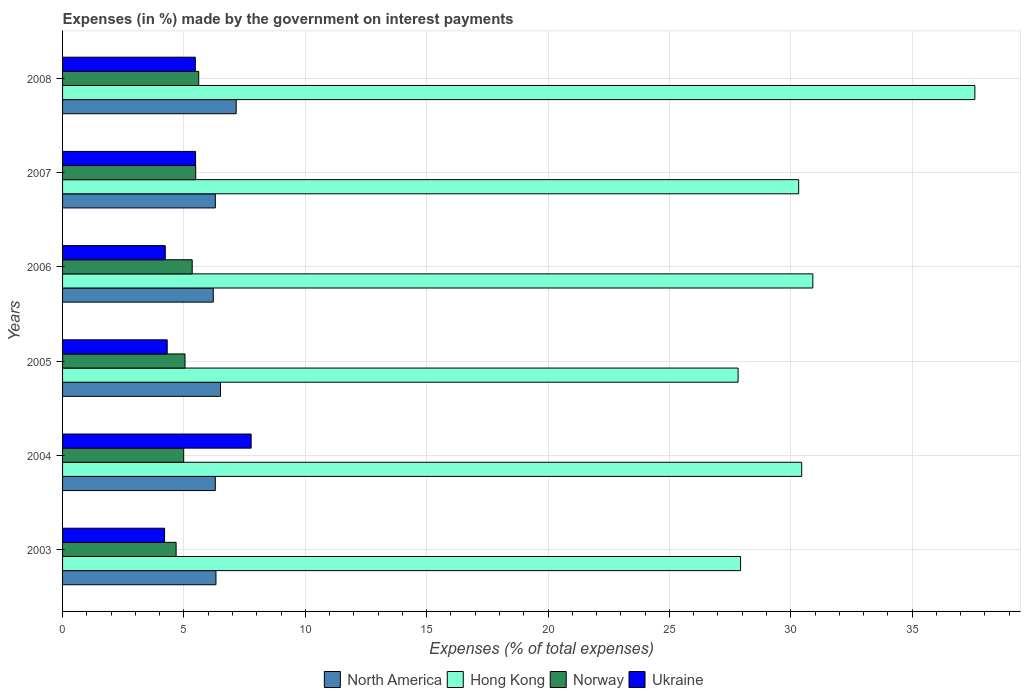How many different coloured bars are there?
Make the answer very short. 4. Are the number of bars per tick equal to the number of legend labels?
Give a very brief answer. Yes. Are the number of bars on each tick of the Y-axis equal?
Keep it short and to the point. Yes. What is the label of the 6th group of bars from the top?
Give a very brief answer. 2003. In how many cases, is the number of bars for a given year not equal to the number of legend labels?
Provide a succinct answer. 0. What is the percentage of expenses made by the government on interest payments in North America in 2003?
Your answer should be compact. 6.32. Across all years, what is the maximum percentage of expenses made by the government on interest payments in Ukraine?
Provide a succinct answer. 7.77. Across all years, what is the minimum percentage of expenses made by the government on interest payments in North America?
Your response must be concise. 6.21. In which year was the percentage of expenses made by the government on interest payments in Norway maximum?
Your response must be concise. 2008. In which year was the percentage of expenses made by the government on interest payments in Ukraine minimum?
Your answer should be very brief. 2003. What is the total percentage of expenses made by the government on interest payments in North America in the graph?
Make the answer very short. 38.77. What is the difference between the percentage of expenses made by the government on interest payments in Ukraine in 2004 and that in 2007?
Provide a short and direct response. 2.29. What is the difference between the percentage of expenses made by the government on interest payments in Norway in 2004 and the percentage of expenses made by the government on interest payments in Hong Kong in 2007?
Keep it short and to the point. -25.34. What is the average percentage of expenses made by the government on interest payments in Ukraine per year?
Your answer should be very brief. 5.24. In the year 2007, what is the difference between the percentage of expenses made by the government on interest payments in Norway and percentage of expenses made by the government on interest payments in Ukraine?
Give a very brief answer. 0.01. In how many years, is the percentage of expenses made by the government on interest payments in Hong Kong greater than 26 %?
Keep it short and to the point. 6. What is the ratio of the percentage of expenses made by the government on interest payments in Hong Kong in 2003 to that in 2008?
Give a very brief answer. 0.74. Is the percentage of expenses made by the government on interest payments in North America in 2004 less than that in 2007?
Make the answer very short. Yes. Is the difference between the percentage of expenses made by the government on interest payments in Norway in 2003 and 2005 greater than the difference between the percentage of expenses made by the government on interest payments in Ukraine in 2003 and 2005?
Your response must be concise. No. What is the difference between the highest and the second highest percentage of expenses made by the government on interest payments in North America?
Keep it short and to the point. 0.65. What is the difference between the highest and the lowest percentage of expenses made by the government on interest payments in Hong Kong?
Provide a succinct answer. 9.76. What does the 4th bar from the top in 2008 represents?
Ensure brevity in your answer.  North America. What does the 4th bar from the bottom in 2007 represents?
Provide a succinct answer. Ukraine. Are the values on the major ticks of X-axis written in scientific E-notation?
Your response must be concise. No. How many legend labels are there?
Offer a very short reply. 4. How are the legend labels stacked?
Offer a terse response. Horizontal. What is the title of the graph?
Offer a terse response. Expenses (in %) made by the government on interest payments. Does "Malawi" appear as one of the legend labels in the graph?
Your answer should be compact. No. What is the label or title of the X-axis?
Provide a succinct answer. Expenses (% of total expenses). What is the label or title of the Y-axis?
Make the answer very short. Years. What is the Expenses (% of total expenses) of North America in 2003?
Give a very brief answer. 6.32. What is the Expenses (% of total expenses) of Hong Kong in 2003?
Offer a terse response. 27.93. What is the Expenses (% of total expenses) of Norway in 2003?
Provide a short and direct response. 4.68. What is the Expenses (% of total expenses) of Ukraine in 2003?
Give a very brief answer. 4.2. What is the Expenses (% of total expenses) of North America in 2004?
Your answer should be compact. 6.29. What is the Expenses (% of total expenses) in Hong Kong in 2004?
Make the answer very short. 30.45. What is the Expenses (% of total expenses) in Norway in 2004?
Ensure brevity in your answer.  4.99. What is the Expenses (% of total expenses) in Ukraine in 2004?
Offer a terse response. 7.77. What is the Expenses (% of total expenses) in North America in 2005?
Your answer should be very brief. 6.51. What is the Expenses (% of total expenses) of Hong Kong in 2005?
Your response must be concise. 27.83. What is the Expenses (% of total expenses) in Norway in 2005?
Offer a terse response. 5.04. What is the Expenses (% of total expenses) in Ukraine in 2005?
Keep it short and to the point. 4.31. What is the Expenses (% of total expenses) in North America in 2006?
Offer a very short reply. 6.21. What is the Expenses (% of total expenses) of Hong Kong in 2006?
Offer a very short reply. 30.91. What is the Expenses (% of total expenses) of Norway in 2006?
Give a very brief answer. 5.34. What is the Expenses (% of total expenses) of Ukraine in 2006?
Provide a succinct answer. 4.23. What is the Expenses (% of total expenses) of North America in 2007?
Your answer should be compact. 6.29. What is the Expenses (% of total expenses) of Hong Kong in 2007?
Your answer should be compact. 30.33. What is the Expenses (% of total expenses) in Norway in 2007?
Ensure brevity in your answer.  5.49. What is the Expenses (% of total expenses) in Ukraine in 2007?
Your answer should be very brief. 5.48. What is the Expenses (% of total expenses) of North America in 2008?
Make the answer very short. 7.15. What is the Expenses (% of total expenses) of Hong Kong in 2008?
Give a very brief answer. 37.59. What is the Expenses (% of total expenses) in Norway in 2008?
Keep it short and to the point. 5.61. What is the Expenses (% of total expenses) in Ukraine in 2008?
Make the answer very short. 5.47. Across all years, what is the maximum Expenses (% of total expenses) of North America?
Your answer should be compact. 7.15. Across all years, what is the maximum Expenses (% of total expenses) in Hong Kong?
Provide a succinct answer. 37.59. Across all years, what is the maximum Expenses (% of total expenses) in Norway?
Offer a very short reply. 5.61. Across all years, what is the maximum Expenses (% of total expenses) of Ukraine?
Provide a succinct answer. 7.77. Across all years, what is the minimum Expenses (% of total expenses) of North America?
Ensure brevity in your answer.  6.21. Across all years, what is the minimum Expenses (% of total expenses) of Hong Kong?
Your response must be concise. 27.83. Across all years, what is the minimum Expenses (% of total expenses) in Norway?
Provide a succinct answer. 4.68. Across all years, what is the minimum Expenses (% of total expenses) of Ukraine?
Offer a very short reply. 4.2. What is the total Expenses (% of total expenses) of North America in the graph?
Give a very brief answer. 38.77. What is the total Expenses (% of total expenses) of Hong Kong in the graph?
Give a very brief answer. 185.04. What is the total Expenses (% of total expenses) in Norway in the graph?
Your response must be concise. 31.15. What is the total Expenses (% of total expenses) in Ukraine in the graph?
Your answer should be compact. 31.46. What is the difference between the Expenses (% of total expenses) in North America in 2003 and that in 2004?
Provide a short and direct response. 0.03. What is the difference between the Expenses (% of total expenses) in Hong Kong in 2003 and that in 2004?
Ensure brevity in your answer.  -2.52. What is the difference between the Expenses (% of total expenses) of Norway in 2003 and that in 2004?
Keep it short and to the point. -0.31. What is the difference between the Expenses (% of total expenses) of Ukraine in 2003 and that in 2004?
Your answer should be very brief. -3.57. What is the difference between the Expenses (% of total expenses) of North America in 2003 and that in 2005?
Your answer should be compact. -0.19. What is the difference between the Expenses (% of total expenses) of Hong Kong in 2003 and that in 2005?
Keep it short and to the point. 0.1. What is the difference between the Expenses (% of total expenses) in Norway in 2003 and that in 2005?
Give a very brief answer. -0.37. What is the difference between the Expenses (% of total expenses) of Ukraine in 2003 and that in 2005?
Ensure brevity in your answer.  -0.11. What is the difference between the Expenses (% of total expenses) in North America in 2003 and that in 2006?
Your answer should be compact. 0.11. What is the difference between the Expenses (% of total expenses) of Hong Kong in 2003 and that in 2006?
Offer a terse response. -2.98. What is the difference between the Expenses (% of total expenses) of Norway in 2003 and that in 2006?
Make the answer very short. -0.66. What is the difference between the Expenses (% of total expenses) in Ukraine in 2003 and that in 2006?
Offer a terse response. -0.03. What is the difference between the Expenses (% of total expenses) of North America in 2003 and that in 2007?
Your answer should be compact. 0.03. What is the difference between the Expenses (% of total expenses) of Hong Kong in 2003 and that in 2007?
Provide a succinct answer. -2.39. What is the difference between the Expenses (% of total expenses) in Norway in 2003 and that in 2007?
Give a very brief answer. -0.81. What is the difference between the Expenses (% of total expenses) of Ukraine in 2003 and that in 2007?
Give a very brief answer. -1.28. What is the difference between the Expenses (% of total expenses) in North America in 2003 and that in 2008?
Keep it short and to the point. -0.83. What is the difference between the Expenses (% of total expenses) of Hong Kong in 2003 and that in 2008?
Your answer should be very brief. -9.65. What is the difference between the Expenses (% of total expenses) in Norway in 2003 and that in 2008?
Provide a short and direct response. -0.93. What is the difference between the Expenses (% of total expenses) in Ukraine in 2003 and that in 2008?
Your answer should be compact. -1.27. What is the difference between the Expenses (% of total expenses) in North America in 2004 and that in 2005?
Give a very brief answer. -0.21. What is the difference between the Expenses (% of total expenses) in Hong Kong in 2004 and that in 2005?
Keep it short and to the point. 2.62. What is the difference between the Expenses (% of total expenses) in Norway in 2004 and that in 2005?
Make the answer very short. -0.05. What is the difference between the Expenses (% of total expenses) of Ukraine in 2004 and that in 2005?
Give a very brief answer. 3.46. What is the difference between the Expenses (% of total expenses) of North America in 2004 and that in 2006?
Give a very brief answer. 0.08. What is the difference between the Expenses (% of total expenses) in Hong Kong in 2004 and that in 2006?
Make the answer very short. -0.46. What is the difference between the Expenses (% of total expenses) in Norway in 2004 and that in 2006?
Your answer should be compact. -0.35. What is the difference between the Expenses (% of total expenses) in Ukraine in 2004 and that in 2006?
Your response must be concise. 3.54. What is the difference between the Expenses (% of total expenses) in North America in 2004 and that in 2007?
Give a very brief answer. -0. What is the difference between the Expenses (% of total expenses) in Hong Kong in 2004 and that in 2007?
Offer a very short reply. 0.12. What is the difference between the Expenses (% of total expenses) in Norway in 2004 and that in 2007?
Give a very brief answer. -0.5. What is the difference between the Expenses (% of total expenses) in Ukraine in 2004 and that in 2007?
Provide a short and direct response. 2.29. What is the difference between the Expenses (% of total expenses) in North America in 2004 and that in 2008?
Provide a short and direct response. -0.86. What is the difference between the Expenses (% of total expenses) in Hong Kong in 2004 and that in 2008?
Offer a terse response. -7.13. What is the difference between the Expenses (% of total expenses) of Norway in 2004 and that in 2008?
Keep it short and to the point. -0.62. What is the difference between the Expenses (% of total expenses) in Ukraine in 2004 and that in 2008?
Give a very brief answer. 2.3. What is the difference between the Expenses (% of total expenses) in North America in 2005 and that in 2006?
Make the answer very short. 0.3. What is the difference between the Expenses (% of total expenses) in Hong Kong in 2005 and that in 2006?
Your answer should be very brief. -3.08. What is the difference between the Expenses (% of total expenses) in Norway in 2005 and that in 2006?
Your answer should be very brief. -0.3. What is the difference between the Expenses (% of total expenses) in North America in 2005 and that in 2007?
Provide a short and direct response. 0.21. What is the difference between the Expenses (% of total expenses) in Hong Kong in 2005 and that in 2007?
Offer a terse response. -2.5. What is the difference between the Expenses (% of total expenses) of Norway in 2005 and that in 2007?
Your answer should be compact. -0.44. What is the difference between the Expenses (% of total expenses) in Ukraine in 2005 and that in 2007?
Ensure brevity in your answer.  -1.17. What is the difference between the Expenses (% of total expenses) of North America in 2005 and that in 2008?
Make the answer very short. -0.65. What is the difference between the Expenses (% of total expenses) in Hong Kong in 2005 and that in 2008?
Your response must be concise. -9.76. What is the difference between the Expenses (% of total expenses) in Norway in 2005 and that in 2008?
Your response must be concise. -0.57. What is the difference between the Expenses (% of total expenses) in Ukraine in 2005 and that in 2008?
Keep it short and to the point. -1.16. What is the difference between the Expenses (% of total expenses) of North America in 2006 and that in 2007?
Your answer should be very brief. -0.08. What is the difference between the Expenses (% of total expenses) of Hong Kong in 2006 and that in 2007?
Offer a terse response. 0.58. What is the difference between the Expenses (% of total expenses) of Norway in 2006 and that in 2007?
Offer a terse response. -0.15. What is the difference between the Expenses (% of total expenses) of Ukraine in 2006 and that in 2007?
Your answer should be very brief. -1.25. What is the difference between the Expenses (% of total expenses) of North America in 2006 and that in 2008?
Your response must be concise. -0.94. What is the difference between the Expenses (% of total expenses) in Hong Kong in 2006 and that in 2008?
Provide a succinct answer. -6.68. What is the difference between the Expenses (% of total expenses) in Norway in 2006 and that in 2008?
Offer a terse response. -0.27. What is the difference between the Expenses (% of total expenses) in Ukraine in 2006 and that in 2008?
Your answer should be very brief. -1.24. What is the difference between the Expenses (% of total expenses) in North America in 2007 and that in 2008?
Provide a short and direct response. -0.86. What is the difference between the Expenses (% of total expenses) in Hong Kong in 2007 and that in 2008?
Your answer should be compact. -7.26. What is the difference between the Expenses (% of total expenses) of Norway in 2007 and that in 2008?
Ensure brevity in your answer.  -0.12. What is the difference between the Expenses (% of total expenses) in Ukraine in 2007 and that in 2008?
Your response must be concise. 0.01. What is the difference between the Expenses (% of total expenses) of North America in 2003 and the Expenses (% of total expenses) of Hong Kong in 2004?
Keep it short and to the point. -24.13. What is the difference between the Expenses (% of total expenses) in North America in 2003 and the Expenses (% of total expenses) in Norway in 2004?
Provide a short and direct response. 1.33. What is the difference between the Expenses (% of total expenses) in North America in 2003 and the Expenses (% of total expenses) in Ukraine in 2004?
Offer a terse response. -1.45. What is the difference between the Expenses (% of total expenses) in Hong Kong in 2003 and the Expenses (% of total expenses) in Norway in 2004?
Offer a terse response. 22.94. What is the difference between the Expenses (% of total expenses) in Hong Kong in 2003 and the Expenses (% of total expenses) in Ukraine in 2004?
Give a very brief answer. 20.16. What is the difference between the Expenses (% of total expenses) in Norway in 2003 and the Expenses (% of total expenses) in Ukraine in 2004?
Make the answer very short. -3.09. What is the difference between the Expenses (% of total expenses) in North America in 2003 and the Expenses (% of total expenses) in Hong Kong in 2005?
Ensure brevity in your answer.  -21.51. What is the difference between the Expenses (% of total expenses) in North America in 2003 and the Expenses (% of total expenses) in Norway in 2005?
Offer a terse response. 1.28. What is the difference between the Expenses (% of total expenses) of North America in 2003 and the Expenses (% of total expenses) of Ukraine in 2005?
Offer a very short reply. 2.01. What is the difference between the Expenses (% of total expenses) in Hong Kong in 2003 and the Expenses (% of total expenses) in Norway in 2005?
Give a very brief answer. 22.89. What is the difference between the Expenses (% of total expenses) in Hong Kong in 2003 and the Expenses (% of total expenses) in Ukraine in 2005?
Keep it short and to the point. 23.62. What is the difference between the Expenses (% of total expenses) in Norway in 2003 and the Expenses (% of total expenses) in Ukraine in 2005?
Ensure brevity in your answer.  0.37. What is the difference between the Expenses (% of total expenses) in North America in 2003 and the Expenses (% of total expenses) in Hong Kong in 2006?
Your response must be concise. -24.59. What is the difference between the Expenses (% of total expenses) in North America in 2003 and the Expenses (% of total expenses) in Norway in 2006?
Ensure brevity in your answer.  0.98. What is the difference between the Expenses (% of total expenses) of North America in 2003 and the Expenses (% of total expenses) of Ukraine in 2006?
Keep it short and to the point. 2.09. What is the difference between the Expenses (% of total expenses) in Hong Kong in 2003 and the Expenses (% of total expenses) in Norway in 2006?
Offer a very short reply. 22.59. What is the difference between the Expenses (% of total expenses) of Hong Kong in 2003 and the Expenses (% of total expenses) of Ukraine in 2006?
Keep it short and to the point. 23.7. What is the difference between the Expenses (% of total expenses) in Norway in 2003 and the Expenses (% of total expenses) in Ukraine in 2006?
Ensure brevity in your answer.  0.45. What is the difference between the Expenses (% of total expenses) in North America in 2003 and the Expenses (% of total expenses) in Hong Kong in 2007?
Ensure brevity in your answer.  -24.01. What is the difference between the Expenses (% of total expenses) of North America in 2003 and the Expenses (% of total expenses) of Norway in 2007?
Keep it short and to the point. 0.83. What is the difference between the Expenses (% of total expenses) in North America in 2003 and the Expenses (% of total expenses) in Ukraine in 2007?
Your response must be concise. 0.84. What is the difference between the Expenses (% of total expenses) of Hong Kong in 2003 and the Expenses (% of total expenses) of Norway in 2007?
Make the answer very short. 22.45. What is the difference between the Expenses (% of total expenses) in Hong Kong in 2003 and the Expenses (% of total expenses) in Ukraine in 2007?
Give a very brief answer. 22.45. What is the difference between the Expenses (% of total expenses) of Norway in 2003 and the Expenses (% of total expenses) of Ukraine in 2007?
Give a very brief answer. -0.8. What is the difference between the Expenses (% of total expenses) of North America in 2003 and the Expenses (% of total expenses) of Hong Kong in 2008?
Offer a very short reply. -31.27. What is the difference between the Expenses (% of total expenses) in North America in 2003 and the Expenses (% of total expenses) in Norway in 2008?
Offer a terse response. 0.71. What is the difference between the Expenses (% of total expenses) of North America in 2003 and the Expenses (% of total expenses) of Ukraine in 2008?
Give a very brief answer. 0.85. What is the difference between the Expenses (% of total expenses) in Hong Kong in 2003 and the Expenses (% of total expenses) in Norway in 2008?
Make the answer very short. 22.32. What is the difference between the Expenses (% of total expenses) of Hong Kong in 2003 and the Expenses (% of total expenses) of Ukraine in 2008?
Offer a very short reply. 22.46. What is the difference between the Expenses (% of total expenses) of Norway in 2003 and the Expenses (% of total expenses) of Ukraine in 2008?
Your answer should be compact. -0.79. What is the difference between the Expenses (% of total expenses) in North America in 2004 and the Expenses (% of total expenses) in Hong Kong in 2005?
Make the answer very short. -21.54. What is the difference between the Expenses (% of total expenses) in North America in 2004 and the Expenses (% of total expenses) in Norway in 2005?
Make the answer very short. 1.25. What is the difference between the Expenses (% of total expenses) of North America in 2004 and the Expenses (% of total expenses) of Ukraine in 2005?
Ensure brevity in your answer.  1.98. What is the difference between the Expenses (% of total expenses) of Hong Kong in 2004 and the Expenses (% of total expenses) of Norway in 2005?
Give a very brief answer. 25.41. What is the difference between the Expenses (% of total expenses) in Hong Kong in 2004 and the Expenses (% of total expenses) in Ukraine in 2005?
Ensure brevity in your answer.  26.14. What is the difference between the Expenses (% of total expenses) of Norway in 2004 and the Expenses (% of total expenses) of Ukraine in 2005?
Ensure brevity in your answer.  0.68. What is the difference between the Expenses (% of total expenses) of North America in 2004 and the Expenses (% of total expenses) of Hong Kong in 2006?
Provide a short and direct response. -24.62. What is the difference between the Expenses (% of total expenses) of North America in 2004 and the Expenses (% of total expenses) of Norway in 2006?
Provide a succinct answer. 0.95. What is the difference between the Expenses (% of total expenses) in North America in 2004 and the Expenses (% of total expenses) in Ukraine in 2006?
Your answer should be very brief. 2.06. What is the difference between the Expenses (% of total expenses) of Hong Kong in 2004 and the Expenses (% of total expenses) of Norway in 2006?
Offer a very short reply. 25.11. What is the difference between the Expenses (% of total expenses) in Hong Kong in 2004 and the Expenses (% of total expenses) in Ukraine in 2006?
Ensure brevity in your answer.  26.22. What is the difference between the Expenses (% of total expenses) of Norway in 2004 and the Expenses (% of total expenses) of Ukraine in 2006?
Make the answer very short. 0.76. What is the difference between the Expenses (% of total expenses) of North America in 2004 and the Expenses (% of total expenses) of Hong Kong in 2007?
Provide a succinct answer. -24.03. What is the difference between the Expenses (% of total expenses) of North America in 2004 and the Expenses (% of total expenses) of Norway in 2007?
Give a very brief answer. 0.81. What is the difference between the Expenses (% of total expenses) of North America in 2004 and the Expenses (% of total expenses) of Ukraine in 2007?
Keep it short and to the point. 0.81. What is the difference between the Expenses (% of total expenses) in Hong Kong in 2004 and the Expenses (% of total expenses) in Norway in 2007?
Give a very brief answer. 24.97. What is the difference between the Expenses (% of total expenses) of Hong Kong in 2004 and the Expenses (% of total expenses) of Ukraine in 2007?
Offer a very short reply. 24.97. What is the difference between the Expenses (% of total expenses) in Norway in 2004 and the Expenses (% of total expenses) in Ukraine in 2007?
Your answer should be very brief. -0.49. What is the difference between the Expenses (% of total expenses) in North America in 2004 and the Expenses (% of total expenses) in Hong Kong in 2008?
Offer a very short reply. -31.29. What is the difference between the Expenses (% of total expenses) of North America in 2004 and the Expenses (% of total expenses) of Norway in 2008?
Provide a succinct answer. 0.68. What is the difference between the Expenses (% of total expenses) of North America in 2004 and the Expenses (% of total expenses) of Ukraine in 2008?
Make the answer very short. 0.82. What is the difference between the Expenses (% of total expenses) in Hong Kong in 2004 and the Expenses (% of total expenses) in Norway in 2008?
Offer a very short reply. 24.84. What is the difference between the Expenses (% of total expenses) in Hong Kong in 2004 and the Expenses (% of total expenses) in Ukraine in 2008?
Your answer should be very brief. 24.98. What is the difference between the Expenses (% of total expenses) of Norway in 2004 and the Expenses (% of total expenses) of Ukraine in 2008?
Offer a terse response. -0.48. What is the difference between the Expenses (% of total expenses) in North America in 2005 and the Expenses (% of total expenses) in Hong Kong in 2006?
Give a very brief answer. -24.4. What is the difference between the Expenses (% of total expenses) in North America in 2005 and the Expenses (% of total expenses) in Norway in 2006?
Your answer should be compact. 1.17. What is the difference between the Expenses (% of total expenses) of North America in 2005 and the Expenses (% of total expenses) of Ukraine in 2006?
Provide a short and direct response. 2.27. What is the difference between the Expenses (% of total expenses) in Hong Kong in 2005 and the Expenses (% of total expenses) in Norway in 2006?
Your answer should be compact. 22.49. What is the difference between the Expenses (% of total expenses) in Hong Kong in 2005 and the Expenses (% of total expenses) in Ukraine in 2006?
Your answer should be compact. 23.6. What is the difference between the Expenses (% of total expenses) in Norway in 2005 and the Expenses (% of total expenses) in Ukraine in 2006?
Your answer should be very brief. 0.81. What is the difference between the Expenses (% of total expenses) in North America in 2005 and the Expenses (% of total expenses) in Hong Kong in 2007?
Ensure brevity in your answer.  -23.82. What is the difference between the Expenses (% of total expenses) of North America in 2005 and the Expenses (% of total expenses) of Norway in 2007?
Make the answer very short. 1.02. What is the difference between the Expenses (% of total expenses) of North America in 2005 and the Expenses (% of total expenses) of Ukraine in 2007?
Offer a very short reply. 1.03. What is the difference between the Expenses (% of total expenses) in Hong Kong in 2005 and the Expenses (% of total expenses) in Norway in 2007?
Make the answer very short. 22.34. What is the difference between the Expenses (% of total expenses) of Hong Kong in 2005 and the Expenses (% of total expenses) of Ukraine in 2007?
Offer a terse response. 22.35. What is the difference between the Expenses (% of total expenses) in Norway in 2005 and the Expenses (% of total expenses) in Ukraine in 2007?
Your answer should be compact. -0.43. What is the difference between the Expenses (% of total expenses) of North America in 2005 and the Expenses (% of total expenses) of Hong Kong in 2008?
Provide a succinct answer. -31.08. What is the difference between the Expenses (% of total expenses) in North America in 2005 and the Expenses (% of total expenses) in Norway in 2008?
Offer a very short reply. 0.9. What is the difference between the Expenses (% of total expenses) in North America in 2005 and the Expenses (% of total expenses) in Ukraine in 2008?
Offer a very short reply. 1.04. What is the difference between the Expenses (% of total expenses) in Hong Kong in 2005 and the Expenses (% of total expenses) in Norway in 2008?
Offer a very short reply. 22.22. What is the difference between the Expenses (% of total expenses) of Hong Kong in 2005 and the Expenses (% of total expenses) of Ukraine in 2008?
Your response must be concise. 22.36. What is the difference between the Expenses (% of total expenses) of Norway in 2005 and the Expenses (% of total expenses) of Ukraine in 2008?
Your answer should be very brief. -0.43. What is the difference between the Expenses (% of total expenses) of North America in 2006 and the Expenses (% of total expenses) of Hong Kong in 2007?
Provide a short and direct response. -24.12. What is the difference between the Expenses (% of total expenses) of North America in 2006 and the Expenses (% of total expenses) of Norway in 2007?
Your response must be concise. 0.72. What is the difference between the Expenses (% of total expenses) of North America in 2006 and the Expenses (% of total expenses) of Ukraine in 2007?
Your response must be concise. 0.73. What is the difference between the Expenses (% of total expenses) of Hong Kong in 2006 and the Expenses (% of total expenses) of Norway in 2007?
Provide a succinct answer. 25.42. What is the difference between the Expenses (% of total expenses) in Hong Kong in 2006 and the Expenses (% of total expenses) in Ukraine in 2007?
Keep it short and to the point. 25.43. What is the difference between the Expenses (% of total expenses) of Norway in 2006 and the Expenses (% of total expenses) of Ukraine in 2007?
Give a very brief answer. -0.14. What is the difference between the Expenses (% of total expenses) in North America in 2006 and the Expenses (% of total expenses) in Hong Kong in 2008?
Make the answer very short. -31.38. What is the difference between the Expenses (% of total expenses) in North America in 2006 and the Expenses (% of total expenses) in Norway in 2008?
Your response must be concise. 0.6. What is the difference between the Expenses (% of total expenses) in North America in 2006 and the Expenses (% of total expenses) in Ukraine in 2008?
Ensure brevity in your answer.  0.74. What is the difference between the Expenses (% of total expenses) in Hong Kong in 2006 and the Expenses (% of total expenses) in Norway in 2008?
Keep it short and to the point. 25.3. What is the difference between the Expenses (% of total expenses) of Hong Kong in 2006 and the Expenses (% of total expenses) of Ukraine in 2008?
Your response must be concise. 25.44. What is the difference between the Expenses (% of total expenses) of Norway in 2006 and the Expenses (% of total expenses) of Ukraine in 2008?
Ensure brevity in your answer.  -0.13. What is the difference between the Expenses (% of total expenses) of North America in 2007 and the Expenses (% of total expenses) of Hong Kong in 2008?
Make the answer very short. -31.29. What is the difference between the Expenses (% of total expenses) of North America in 2007 and the Expenses (% of total expenses) of Norway in 2008?
Ensure brevity in your answer.  0.68. What is the difference between the Expenses (% of total expenses) of North America in 2007 and the Expenses (% of total expenses) of Ukraine in 2008?
Give a very brief answer. 0.82. What is the difference between the Expenses (% of total expenses) in Hong Kong in 2007 and the Expenses (% of total expenses) in Norway in 2008?
Your answer should be compact. 24.72. What is the difference between the Expenses (% of total expenses) of Hong Kong in 2007 and the Expenses (% of total expenses) of Ukraine in 2008?
Offer a very short reply. 24.86. What is the difference between the Expenses (% of total expenses) of Norway in 2007 and the Expenses (% of total expenses) of Ukraine in 2008?
Your answer should be compact. 0.02. What is the average Expenses (% of total expenses) of North America per year?
Keep it short and to the point. 6.46. What is the average Expenses (% of total expenses) of Hong Kong per year?
Offer a terse response. 30.84. What is the average Expenses (% of total expenses) of Norway per year?
Your answer should be very brief. 5.19. What is the average Expenses (% of total expenses) of Ukraine per year?
Your answer should be compact. 5.24. In the year 2003, what is the difference between the Expenses (% of total expenses) of North America and Expenses (% of total expenses) of Hong Kong?
Offer a very short reply. -21.61. In the year 2003, what is the difference between the Expenses (% of total expenses) of North America and Expenses (% of total expenses) of Norway?
Offer a terse response. 1.64. In the year 2003, what is the difference between the Expenses (% of total expenses) in North America and Expenses (% of total expenses) in Ukraine?
Keep it short and to the point. 2.12. In the year 2003, what is the difference between the Expenses (% of total expenses) in Hong Kong and Expenses (% of total expenses) in Norway?
Offer a very short reply. 23.25. In the year 2003, what is the difference between the Expenses (% of total expenses) in Hong Kong and Expenses (% of total expenses) in Ukraine?
Keep it short and to the point. 23.73. In the year 2003, what is the difference between the Expenses (% of total expenses) of Norway and Expenses (% of total expenses) of Ukraine?
Ensure brevity in your answer.  0.48. In the year 2004, what is the difference between the Expenses (% of total expenses) in North America and Expenses (% of total expenses) in Hong Kong?
Make the answer very short. -24.16. In the year 2004, what is the difference between the Expenses (% of total expenses) of North America and Expenses (% of total expenses) of Norway?
Offer a terse response. 1.3. In the year 2004, what is the difference between the Expenses (% of total expenses) in North America and Expenses (% of total expenses) in Ukraine?
Offer a very short reply. -1.48. In the year 2004, what is the difference between the Expenses (% of total expenses) of Hong Kong and Expenses (% of total expenses) of Norway?
Offer a very short reply. 25.46. In the year 2004, what is the difference between the Expenses (% of total expenses) in Hong Kong and Expenses (% of total expenses) in Ukraine?
Ensure brevity in your answer.  22.68. In the year 2004, what is the difference between the Expenses (% of total expenses) of Norway and Expenses (% of total expenses) of Ukraine?
Offer a very short reply. -2.78. In the year 2005, what is the difference between the Expenses (% of total expenses) of North America and Expenses (% of total expenses) of Hong Kong?
Offer a terse response. -21.32. In the year 2005, what is the difference between the Expenses (% of total expenses) of North America and Expenses (% of total expenses) of Norway?
Make the answer very short. 1.46. In the year 2005, what is the difference between the Expenses (% of total expenses) in North America and Expenses (% of total expenses) in Ukraine?
Give a very brief answer. 2.19. In the year 2005, what is the difference between the Expenses (% of total expenses) of Hong Kong and Expenses (% of total expenses) of Norway?
Ensure brevity in your answer.  22.79. In the year 2005, what is the difference between the Expenses (% of total expenses) of Hong Kong and Expenses (% of total expenses) of Ukraine?
Offer a terse response. 23.52. In the year 2005, what is the difference between the Expenses (% of total expenses) in Norway and Expenses (% of total expenses) in Ukraine?
Give a very brief answer. 0.73. In the year 2006, what is the difference between the Expenses (% of total expenses) of North America and Expenses (% of total expenses) of Hong Kong?
Make the answer very short. -24.7. In the year 2006, what is the difference between the Expenses (% of total expenses) in North America and Expenses (% of total expenses) in Norway?
Offer a terse response. 0.87. In the year 2006, what is the difference between the Expenses (% of total expenses) in North America and Expenses (% of total expenses) in Ukraine?
Ensure brevity in your answer.  1.98. In the year 2006, what is the difference between the Expenses (% of total expenses) in Hong Kong and Expenses (% of total expenses) in Norway?
Give a very brief answer. 25.57. In the year 2006, what is the difference between the Expenses (% of total expenses) in Hong Kong and Expenses (% of total expenses) in Ukraine?
Your response must be concise. 26.68. In the year 2006, what is the difference between the Expenses (% of total expenses) in Norway and Expenses (% of total expenses) in Ukraine?
Offer a very short reply. 1.11. In the year 2007, what is the difference between the Expenses (% of total expenses) of North America and Expenses (% of total expenses) of Hong Kong?
Keep it short and to the point. -24.03. In the year 2007, what is the difference between the Expenses (% of total expenses) in North America and Expenses (% of total expenses) in Norway?
Offer a terse response. 0.81. In the year 2007, what is the difference between the Expenses (% of total expenses) in North America and Expenses (% of total expenses) in Ukraine?
Make the answer very short. 0.81. In the year 2007, what is the difference between the Expenses (% of total expenses) in Hong Kong and Expenses (% of total expenses) in Norway?
Give a very brief answer. 24.84. In the year 2007, what is the difference between the Expenses (% of total expenses) in Hong Kong and Expenses (% of total expenses) in Ukraine?
Ensure brevity in your answer.  24.85. In the year 2007, what is the difference between the Expenses (% of total expenses) in Norway and Expenses (% of total expenses) in Ukraine?
Provide a short and direct response. 0.01. In the year 2008, what is the difference between the Expenses (% of total expenses) of North America and Expenses (% of total expenses) of Hong Kong?
Your response must be concise. -30.43. In the year 2008, what is the difference between the Expenses (% of total expenses) in North America and Expenses (% of total expenses) in Norway?
Your answer should be compact. 1.54. In the year 2008, what is the difference between the Expenses (% of total expenses) of North America and Expenses (% of total expenses) of Ukraine?
Provide a short and direct response. 1.68. In the year 2008, what is the difference between the Expenses (% of total expenses) of Hong Kong and Expenses (% of total expenses) of Norway?
Your answer should be very brief. 31.98. In the year 2008, what is the difference between the Expenses (% of total expenses) in Hong Kong and Expenses (% of total expenses) in Ukraine?
Provide a short and direct response. 32.12. In the year 2008, what is the difference between the Expenses (% of total expenses) in Norway and Expenses (% of total expenses) in Ukraine?
Make the answer very short. 0.14. What is the ratio of the Expenses (% of total expenses) of Hong Kong in 2003 to that in 2004?
Give a very brief answer. 0.92. What is the ratio of the Expenses (% of total expenses) in Ukraine in 2003 to that in 2004?
Offer a very short reply. 0.54. What is the ratio of the Expenses (% of total expenses) of North America in 2003 to that in 2005?
Keep it short and to the point. 0.97. What is the ratio of the Expenses (% of total expenses) of Hong Kong in 2003 to that in 2005?
Provide a short and direct response. 1. What is the ratio of the Expenses (% of total expenses) in Norway in 2003 to that in 2005?
Keep it short and to the point. 0.93. What is the ratio of the Expenses (% of total expenses) in Ukraine in 2003 to that in 2005?
Offer a very short reply. 0.97. What is the ratio of the Expenses (% of total expenses) of North America in 2003 to that in 2006?
Your answer should be very brief. 1.02. What is the ratio of the Expenses (% of total expenses) of Hong Kong in 2003 to that in 2006?
Make the answer very short. 0.9. What is the ratio of the Expenses (% of total expenses) in Norway in 2003 to that in 2006?
Your response must be concise. 0.88. What is the ratio of the Expenses (% of total expenses) in North America in 2003 to that in 2007?
Offer a terse response. 1. What is the ratio of the Expenses (% of total expenses) of Hong Kong in 2003 to that in 2007?
Keep it short and to the point. 0.92. What is the ratio of the Expenses (% of total expenses) of Norway in 2003 to that in 2007?
Offer a very short reply. 0.85. What is the ratio of the Expenses (% of total expenses) in Ukraine in 2003 to that in 2007?
Provide a succinct answer. 0.77. What is the ratio of the Expenses (% of total expenses) in North America in 2003 to that in 2008?
Ensure brevity in your answer.  0.88. What is the ratio of the Expenses (% of total expenses) in Hong Kong in 2003 to that in 2008?
Ensure brevity in your answer.  0.74. What is the ratio of the Expenses (% of total expenses) of Norway in 2003 to that in 2008?
Provide a succinct answer. 0.83. What is the ratio of the Expenses (% of total expenses) in Ukraine in 2003 to that in 2008?
Keep it short and to the point. 0.77. What is the ratio of the Expenses (% of total expenses) of North America in 2004 to that in 2005?
Offer a very short reply. 0.97. What is the ratio of the Expenses (% of total expenses) in Hong Kong in 2004 to that in 2005?
Give a very brief answer. 1.09. What is the ratio of the Expenses (% of total expenses) in Norway in 2004 to that in 2005?
Keep it short and to the point. 0.99. What is the ratio of the Expenses (% of total expenses) in Ukraine in 2004 to that in 2005?
Make the answer very short. 1.8. What is the ratio of the Expenses (% of total expenses) in North America in 2004 to that in 2006?
Your response must be concise. 1.01. What is the ratio of the Expenses (% of total expenses) in Hong Kong in 2004 to that in 2006?
Offer a very short reply. 0.99. What is the ratio of the Expenses (% of total expenses) in Norway in 2004 to that in 2006?
Give a very brief answer. 0.93. What is the ratio of the Expenses (% of total expenses) of Ukraine in 2004 to that in 2006?
Give a very brief answer. 1.84. What is the ratio of the Expenses (% of total expenses) in North America in 2004 to that in 2007?
Provide a succinct answer. 1. What is the ratio of the Expenses (% of total expenses) of Hong Kong in 2004 to that in 2007?
Make the answer very short. 1. What is the ratio of the Expenses (% of total expenses) of Norway in 2004 to that in 2007?
Your answer should be very brief. 0.91. What is the ratio of the Expenses (% of total expenses) of Ukraine in 2004 to that in 2007?
Offer a terse response. 1.42. What is the ratio of the Expenses (% of total expenses) in North America in 2004 to that in 2008?
Your answer should be very brief. 0.88. What is the ratio of the Expenses (% of total expenses) of Hong Kong in 2004 to that in 2008?
Give a very brief answer. 0.81. What is the ratio of the Expenses (% of total expenses) in Norway in 2004 to that in 2008?
Make the answer very short. 0.89. What is the ratio of the Expenses (% of total expenses) of Ukraine in 2004 to that in 2008?
Offer a very short reply. 1.42. What is the ratio of the Expenses (% of total expenses) of North America in 2005 to that in 2006?
Provide a short and direct response. 1.05. What is the ratio of the Expenses (% of total expenses) of Hong Kong in 2005 to that in 2006?
Make the answer very short. 0.9. What is the ratio of the Expenses (% of total expenses) of Norway in 2005 to that in 2006?
Give a very brief answer. 0.94. What is the ratio of the Expenses (% of total expenses) in Ukraine in 2005 to that in 2006?
Your answer should be compact. 1.02. What is the ratio of the Expenses (% of total expenses) of North America in 2005 to that in 2007?
Ensure brevity in your answer.  1.03. What is the ratio of the Expenses (% of total expenses) of Hong Kong in 2005 to that in 2007?
Your answer should be compact. 0.92. What is the ratio of the Expenses (% of total expenses) of Norway in 2005 to that in 2007?
Your response must be concise. 0.92. What is the ratio of the Expenses (% of total expenses) in Ukraine in 2005 to that in 2007?
Your response must be concise. 0.79. What is the ratio of the Expenses (% of total expenses) in North America in 2005 to that in 2008?
Offer a terse response. 0.91. What is the ratio of the Expenses (% of total expenses) of Hong Kong in 2005 to that in 2008?
Your answer should be compact. 0.74. What is the ratio of the Expenses (% of total expenses) of Norway in 2005 to that in 2008?
Your response must be concise. 0.9. What is the ratio of the Expenses (% of total expenses) of Ukraine in 2005 to that in 2008?
Offer a very short reply. 0.79. What is the ratio of the Expenses (% of total expenses) of North America in 2006 to that in 2007?
Make the answer very short. 0.99. What is the ratio of the Expenses (% of total expenses) in Hong Kong in 2006 to that in 2007?
Give a very brief answer. 1.02. What is the ratio of the Expenses (% of total expenses) of Norway in 2006 to that in 2007?
Provide a short and direct response. 0.97. What is the ratio of the Expenses (% of total expenses) of Ukraine in 2006 to that in 2007?
Ensure brevity in your answer.  0.77. What is the ratio of the Expenses (% of total expenses) in North America in 2006 to that in 2008?
Keep it short and to the point. 0.87. What is the ratio of the Expenses (% of total expenses) in Hong Kong in 2006 to that in 2008?
Your answer should be very brief. 0.82. What is the ratio of the Expenses (% of total expenses) in Norway in 2006 to that in 2008?
Provide a short and direct response. 0.95. What is the ratio of the Expenses (% of total expenses) in Ukraine in 2006 to that in 2008?
Offer a terse response. 0.77. What is the ratio of the Expenses (% of total expenses) of North America in 2007 to that in 2008?
Keep it short and to the point. 0.88. What is the ratio of the Expenses (% of total expenses) of Hong Kong in 2007 to that in 2008?
Make the answer very short. 0.81. What is the ratio of the Expenses (% of total expenses) in Norway in 2007 to that in 2008?
Give a very brief answer. 0.98. What is the ratio of the Expenses (% of total expenses) of Ukraine in 2007 to that in 2008?
Give a very brief answer. 1. What is the difference between the highest and the second highest Expenses (% of total expenses) in North America?
Provide a succinct answer. 0.65. What is the difference between the highest and the second highest Expenses (% of total expenses) in Hong Kong?
Offer a terse response. 6.68. What is the difference between the highest and the second highest Expenses (% of total expenses) in Norway?
Your answer should be very brief. 0.12. What is the difference between the highest and the second highest Expenses (% of total expenses) in Ukraine?
Your response must be concise. 2.29. What is the difference between the highest and the lowest Expenses (% of total expenses) of North America?
Your response must be concise. 0.94. What is the difference between the highest and the lowest Expenses (% of total expenses) in Hong Kong?
Your response must be concise. 9.76. What is the difference between the highest and the lowest Expenses (% of total expenses) of Norway?
Make the answer very short. 0.93. What is the difference between the highest and the lowest Expenses (% of total expenses) of Ukraine?
Make the answer very short. 3.57. 